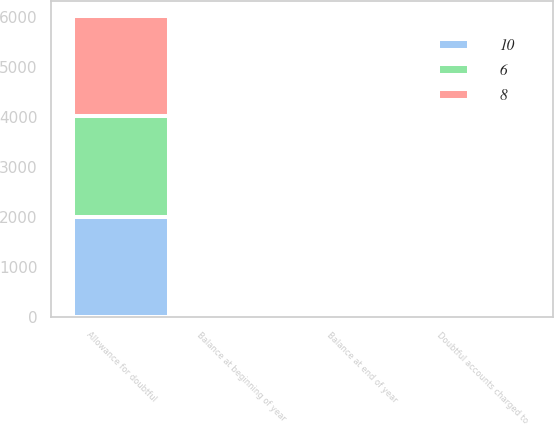<chart> <loc_0><loc_0><loc_500><loc_500><stacked_bar_chart><ecel><fcel>Allowance for doubtful<fcel>Balance at beginning of year<fcel>Doubtful accounts charged to<fcel>Balance at end of year<nl><fcel>10<fcel>2012<fcel>8<fcel>3<fcel>6<nl><fcel>8<fcel>2011<fcel>10<fcel>2<fcel>8<nl><fcel>6<fcel>2010<fcel>9<fcel>1<fcel>10<nl></chart> 